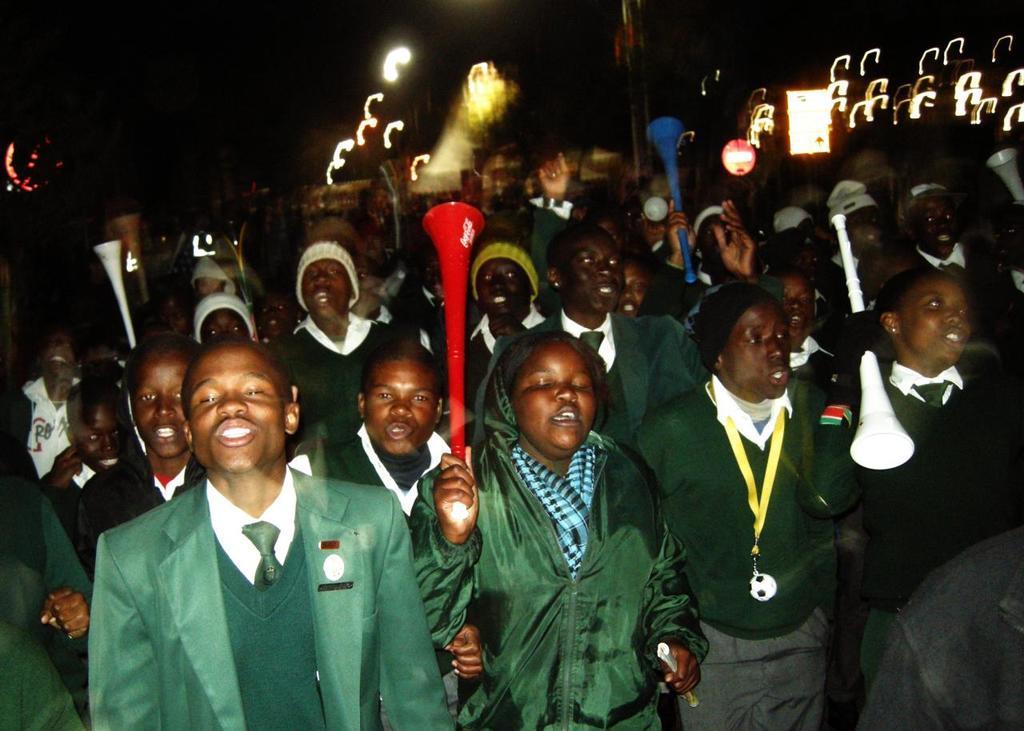Could you give a brief overview of what you see in this image? In this image there are a group of people who are holding some sticks, and it seems that they are talking something. In the background there are some lights and some objects. 